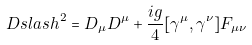Convert formula to latex. <formula><loc_0><loc_0><loc_500><loc_500>\ D s l a s h ^ { 2 } = D _ { \mu } D ^ { \mu } + \frac { i g } { 4 } [ \gamma ^ { \mu } , \gamma ^ { \nu } ] F _ { \mu \nu }</formula> 